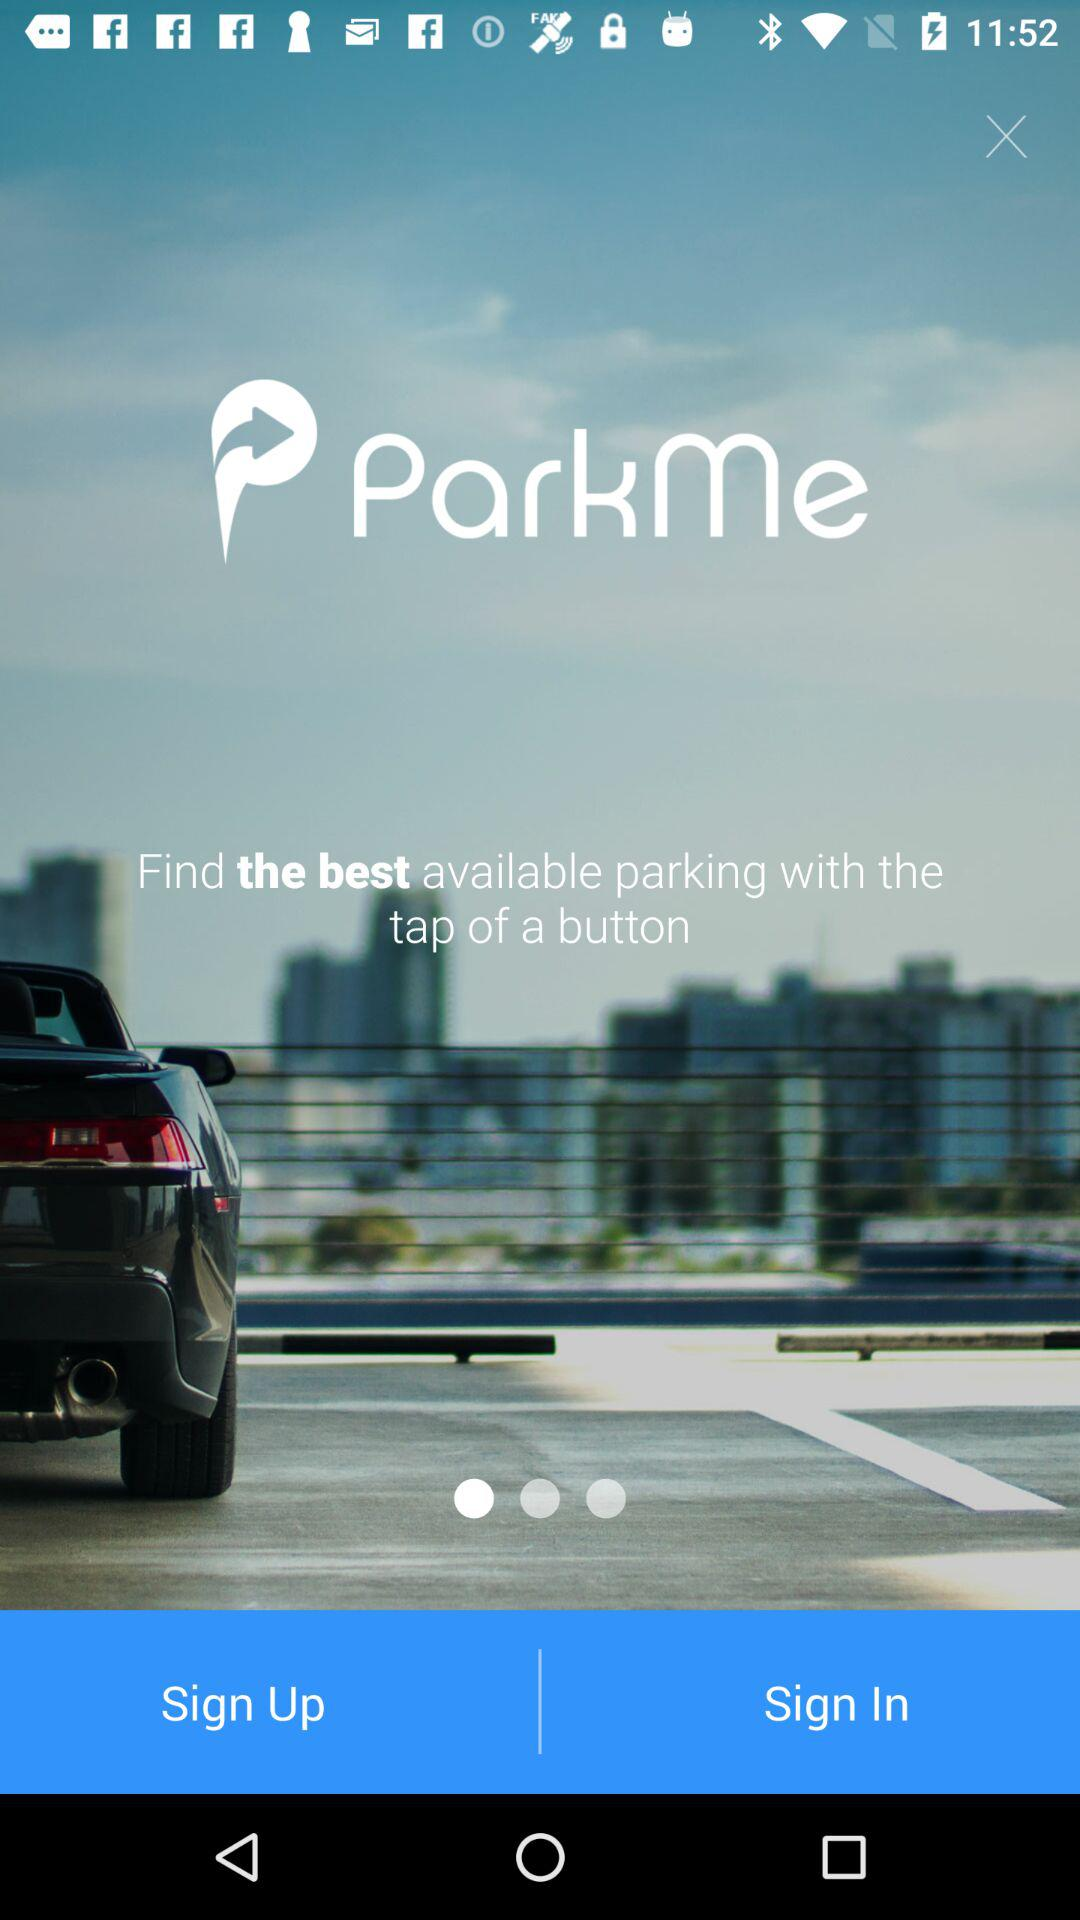What is the name of the application? The name of the application is "ParkMe". 